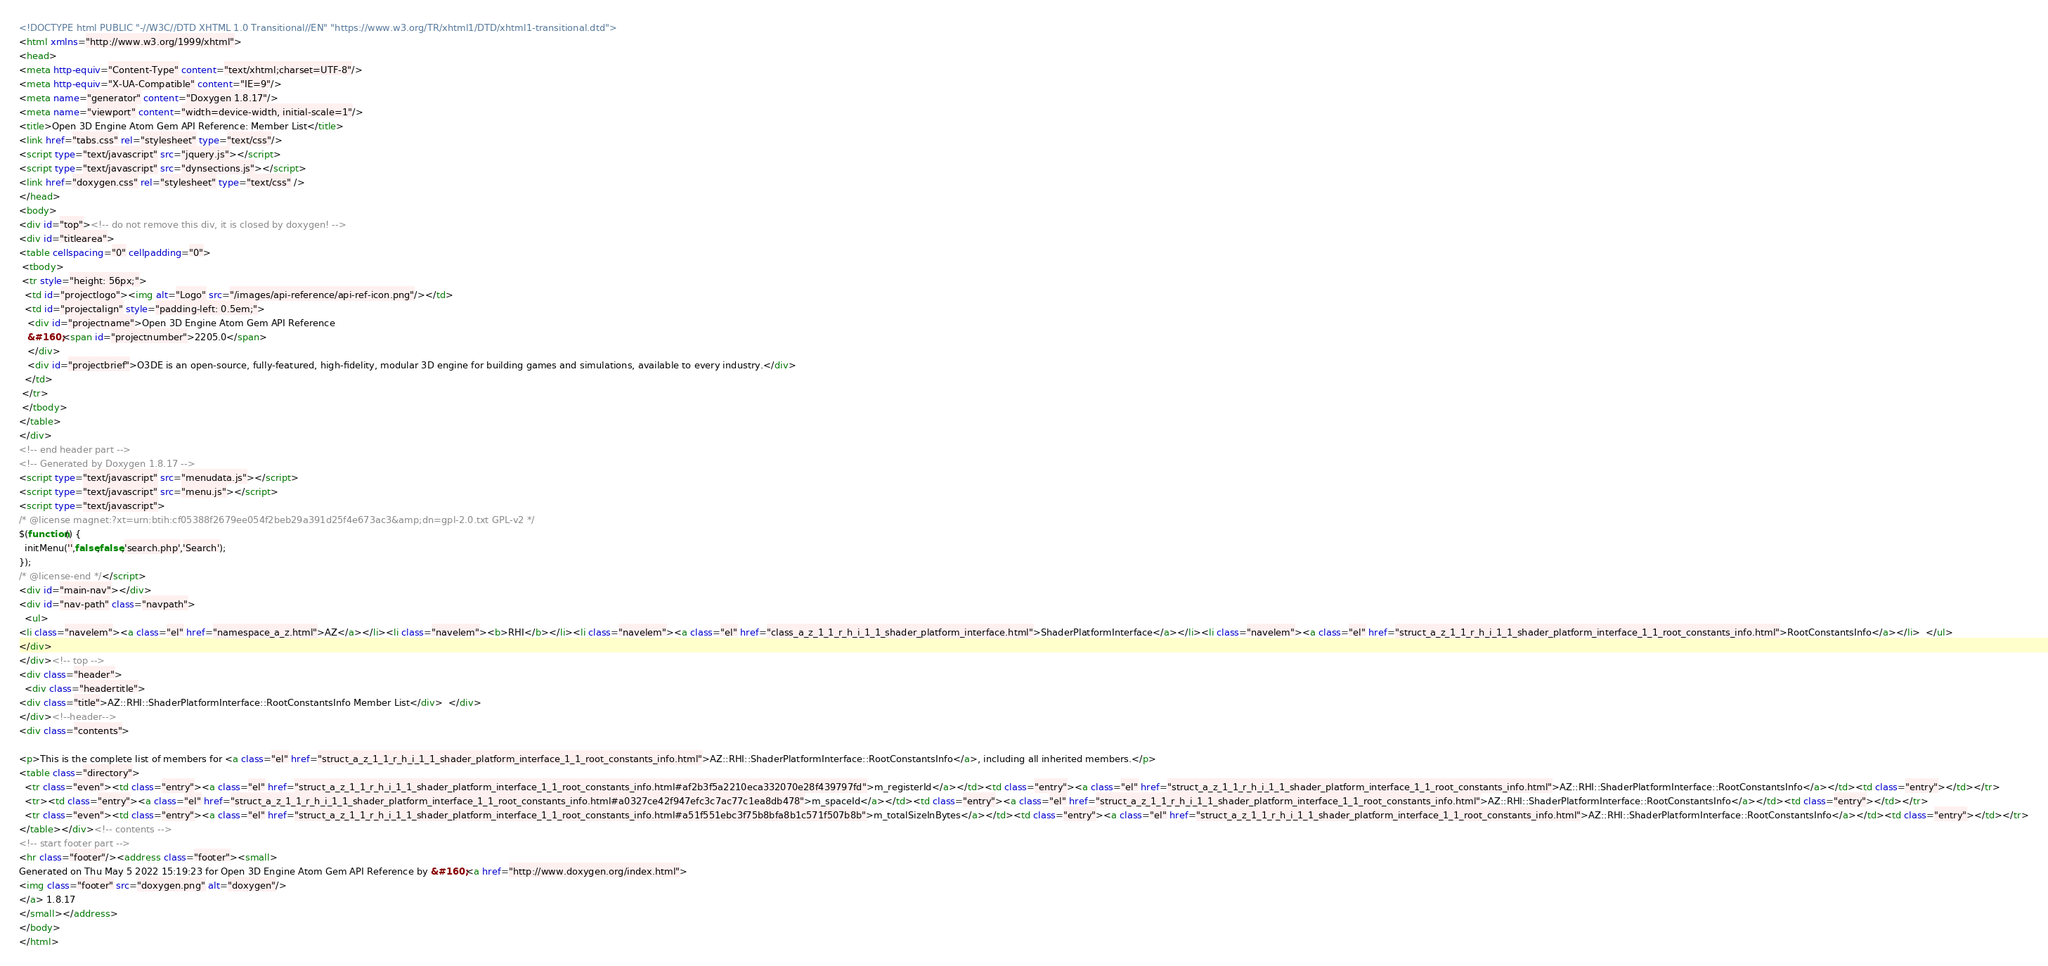Convert code to text. <code><loc_0><loc_0><loc_500><loc_500><_HTML_><!DOCTYPE html PUBLIC "-//W3C//DTD XHTML 1.0 Transitional//EN" "https://www.w3.org/TR/xhtml1/DTD/xhtml1-transitional.dtd">
<html xmlns="http://www.w3.org/1999/xhtml">
<head>
<meta http-equiv="Content-Type" content="text/xhtml;charset=UTF-8"/>
<meta http-equiv="X-UA-Compatible" content="IE=9"/>
<meta name="generator" content="Doxygen 1.8.17"/>
<meta name="viewport" content="width=device-width, initial-scale=1"/>
<title>Open 3D Engine Atom Gem API Reference: Member List</title>
<link href="tabs.css" rel="stylesheet" type="text/css"/>
<script type="text/javascript" src="jquery.js"></script>
<script type="text/javascript" src="dynsections.js"></script>
<link href="doxygen.css" rel="stylesheet" type="text/css" />
</head>
<body>
<div id="top"><!-- do not remove this div, it is closed by doxygen! -->
<div id="titlearea">
<table cellspacing="0" cellpadding="0">
 <tbody>
 <tr style="height: 56px;">
  <td id="projectlogo"><img alt="Logo" src="/images/api-reference/api-ref-icon.png"/></td>
  <td id="projectalign" style="padding-left: 0.5em;">
   <div id="projectname">Open 3D Engine Atom Gem API Reference
   &#160;<span id="projectnumber">2205.0</span>
   </div>
   <div id="projectbrief">O3DE is an open-source, fully-featured, high-fidelity, modular 3D engine for building games and simulations, available to every industry.</div>
  </td>
 </tr>
 </tbody>
</table>
</div>
<!-- end header part -->
<!-- Generated by Doxygen 1.8.17 -->
<script type="text/javascript" src="menudata.js"></script>
<script type="text/javascript" src="menu.js"></script>
<script type="text/javascript">
/* @license magnet:?xt=urn:btih:cf05388f2679ee054f2beb29a391d25f4e673ac3&amp;dn=gpl-2.0.txt GPL-v2 */
$(function() {
  initMenu('',false,false,'search.php','Search');
});
/* @license-end */</script>
<div id="main-nav"></div>
<div id="nav-path" class="navpath">
  <ul>
<li class="navelem"><a class="el" href="namespace_a_z.html">AZ</a></li><li class="navelem"><b>RHI</b></li><li class="navelem"><a class="el" href="class_a_z_1_1_r_h_i_1_1_shader_platform_interface.html">ShaderPlatformInterface</a></li><li class="navelem"><a class="el" href="struct_a_z_1_1_r_h_i_1_1_shader_platform_interface_1_1_root_constants_info.html">RootConstantsInfo</a></li>  </ul>
</div>
</div><!-- top -->
<div class="header">
  <div class="headertitle">
<div class="title">AZ::RHI::ShaderPlatformInterface::RootConstantsInfo Member List</div>  </div>
</div><!--header-->
<div class="contents">

<p>This is the complete list of members for <a class="el" href="struct_a_z_1_1_r_h_i_1_1_shader_platform_interface_1_1_root_constants_info.html">AZ::RHI::ShaderPlatformInterface::RootConstantsInfo</a>, including all inherited members.</p>
<table class="directory">
  <tr class="even"><td class="entry"><a class="el" href="struct_a_z_1_1_r_h_i_1_1_shader_platform_interface_1_1_root_constants_info.html#af2b3f5a2210eca332070e28f439797fd">m_registerId</a></td><td class="entry"><a class="el" href="struct_a_z_1_1_r_h_i_1_1_shader_platform_interface_1_1_root_constants_info.html">AZ::RHI::ShaderPlatformInterface::RootConstantsInfo</a></td><td class="entry"></td></tr>
  <tr><td class="entry"><a class="el" href="struct_a_z_1_1_r_h_i_1_1_shader_platform_interface_1_1_root_constants_info.html#a0327ce42f947efc3c7ac77c1ea8db478">m_spaceId</a></td><td class="entry"><a class="el" href="struct_a_z_1_1_r_h_i_1_1_shader_platform_interface_1_1_root_constants_info.html">AZ::RHI::ShaderPlatformInterface::RootConstantsInfo</a></td><td class="entry"></td></tr>
  <tr class="even"><td class="entry"><a class="el" href="struct_a_z_1_1_r_h_i_1_1_shader_platform_interface_1_1_root_constants_info.html#a51f551ebc3f75b8bfa8b1c571f507b8b">m_totalSizeInBytes</a></td><td class="entry"><a class="el" href="struct_a_z_1_1_r_h_i_1_1_shader_platform_interface_1_1_root_constants_info.html">AZ::RHI::ShaderPlatformInterface::RootConstantsInfo</a></td><td class="entry"></td></tr>
</table></div><!-- contents -->
<!-- start footer part -->
<hr class="footer"/><address class="footer"><small>
Generated on Thu May 5 2022 15:19:23 for Open 3D Engine Atom Gem API Reference by &#160;<a href="http://www.doxygen.org/index.html">
<img class="footer" src="doxygen.png" alt="doxygen"/>
</a> 1.8.17
</small></address>
</body>
</html>
</code> 